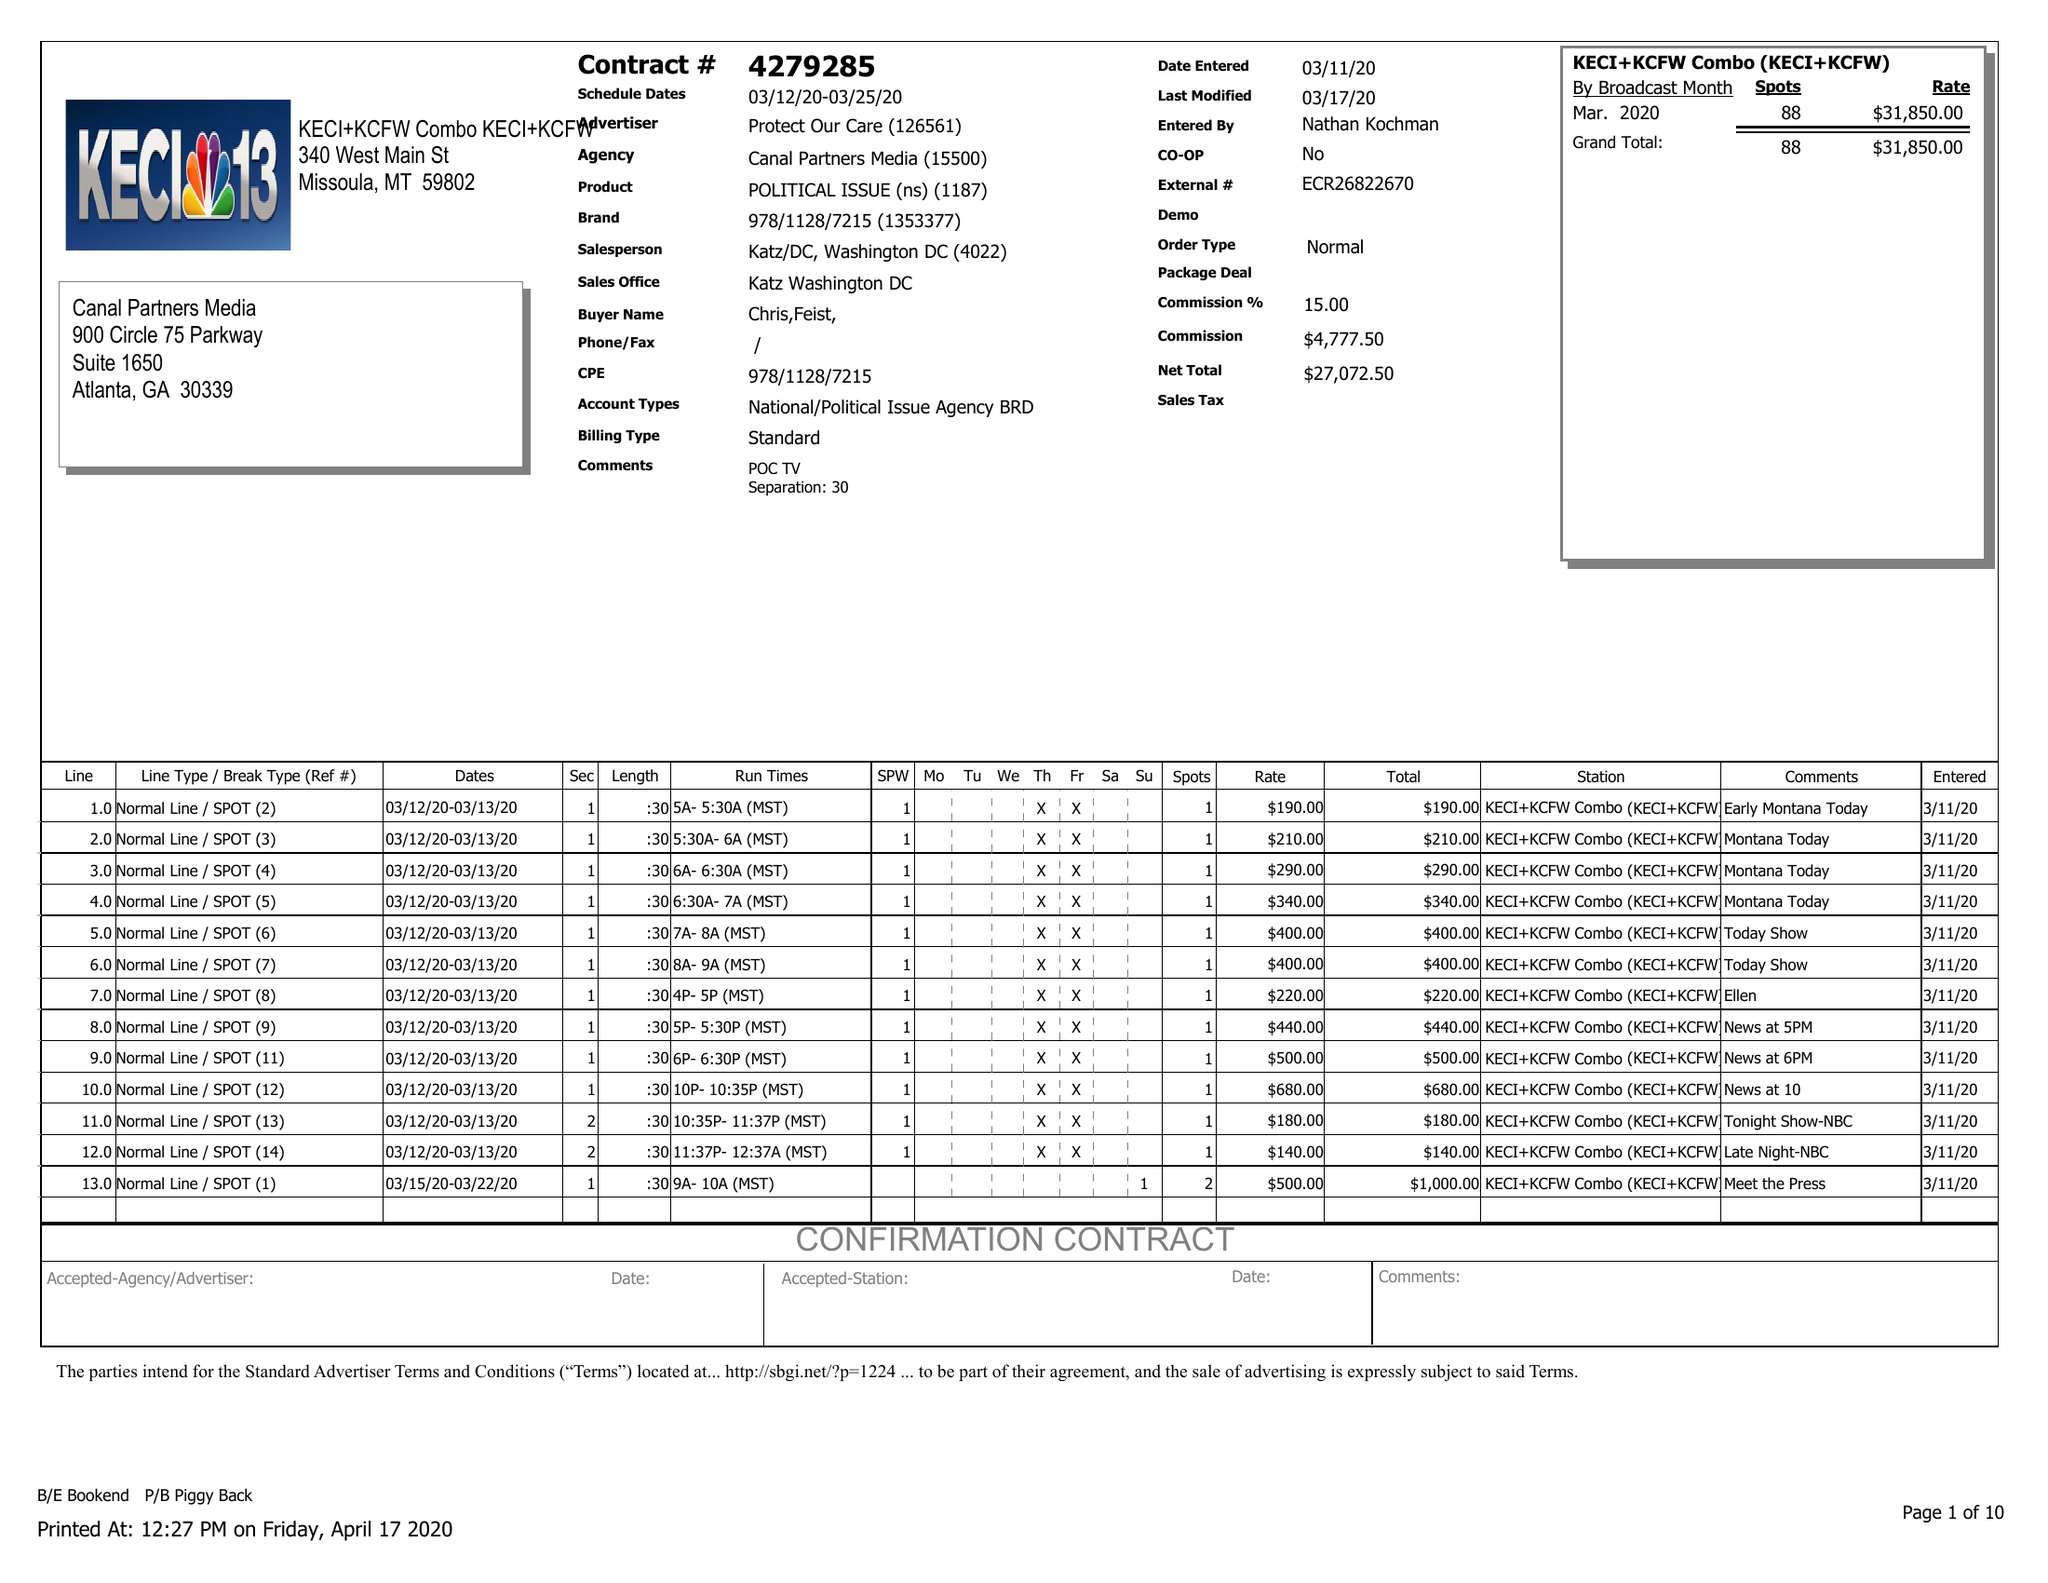What is the value for the flight_to?
Answer the question using a single word or phrase. 03/25/20 